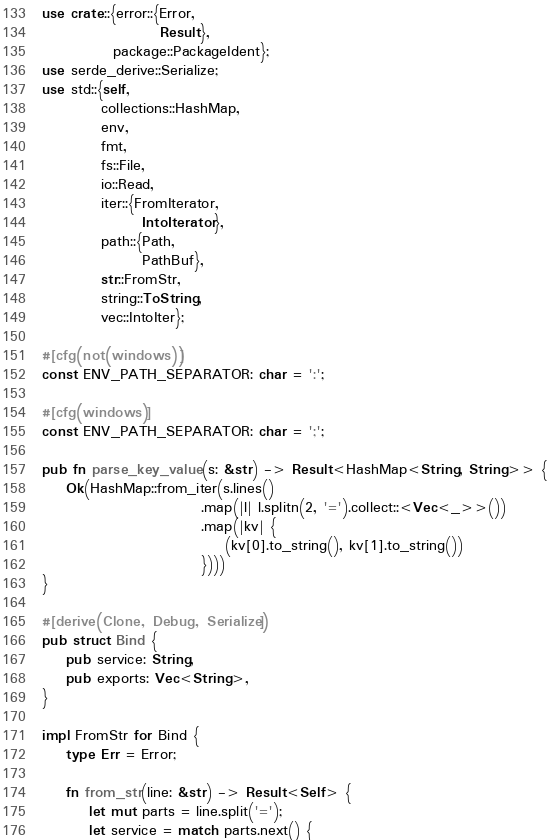Convert code to text. <code><loc_0><loc_0><loc_500><loc_500><_Rust_>use crate::{error::{Error,
                    Result},
            package::PackageIdent};
use serde_derive::Serialize;
use std::{self,
          collections::HashMap,
          env,
          fmt,
          fs::File,
          io::Read,
          iter::{FromIterator,
                 IntoIterator},
          path::{Path,
                 PathBuf},
          str::FromStr,
          string::ToString,
          vec::IntoIter};

#[cfg(not(windows))]
const ENV_PATH_SEPARATOR: char = ':';

#[cfg(windows)]
const ENV_PATH_SEPARATOR: char = ';';

pub fn parse_key_value(s: &str) -> Result<HashMap<String, String>> {
    Ok(HashMap::from_iter(s.lines()
                           .map(|l| l.splitn(2, '=').collect::<Vec<_>>())
                           .map(|kv| {
                               (kv[0].to_string(), kv[1].to_string())
                           })))
}

#[derive(Clone, Debug, Serialize)]
pub struct Bind {
    pub service: String,
    pub exports: Vec<String>,
}

impl FromStr for Bind {
    type Err = Error;

    fn from_str(line: &str) -> Result<Self> {
        let mut parts = line.split('=');
        let service = match parts.next() {</code> 